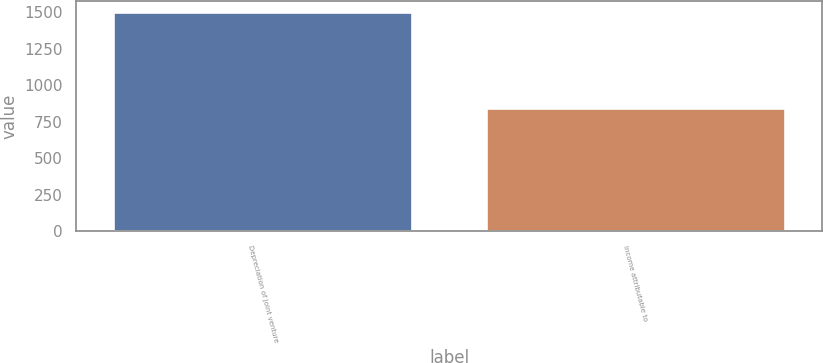<chart> <loc_0><loc_0><loc_500><loc_500><bar_chart><fcel>Depreciation of joint venture<fcel>Income attributable to<nl><fcel>1499<fcel>847<nl></chart> 